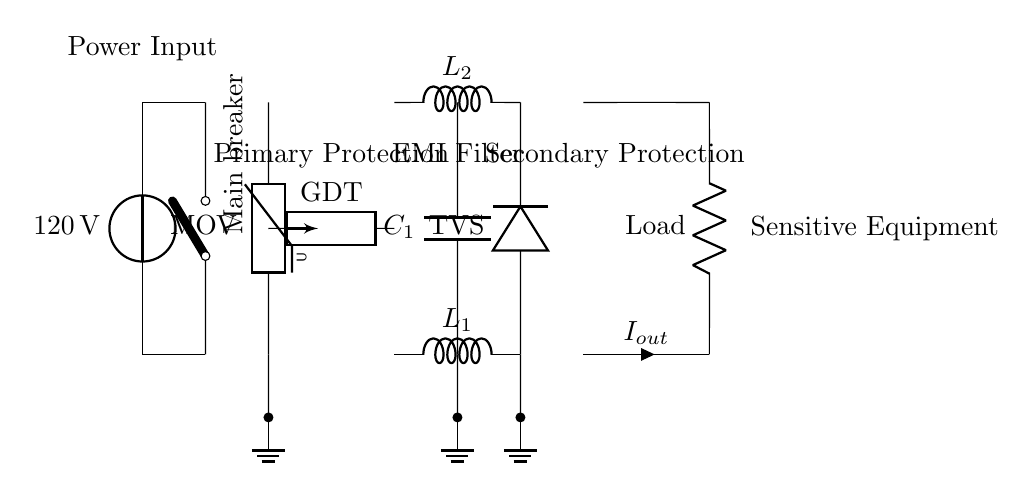What is the type of main power input? The main power input is provided by a voltage source labeled as 120 volts. This is indicated by the vsource symbol at the start of the circuit.
Answer: 120 volts What component provides primary surge protection? The primary surge protection is provided by a metal oxide varistor, as shown by the part labeled MOV in the diagram. This component is specifically designed to clamp voltage spikes.
Answer: MOV How many inductors are in the EMI filter section? The EMI filter section contains two inductors labeled L1 and L2, which are connected in parallel with a capacitor labeled C1. This configuration is common for filtering out electromagnetic interference.
Answer: 2 What type of device is used for secondary protection? The secondary protection is provided by a transient voltage suppressor, indicated by the label TVS next to the corresponding diode symbol. This device is used to protect sensitive equipment from voltage spikes.
Answer: TVS Where are the ground connections located? Ground connections are shown at three different points in the circuit, marked by ground symbols connected to the MOV, C1, and TVS. These connections help to safely redirect excess voltage to the ground.
Answer: Three points What is the expected output current labeled as? The expected output current is labeled as Iout in the circuit, indicating the current that flows to the sensitive equipment. This is shown as an arrow with the label next to it, guiding from the circuit output to the load.
Answer: Iout What is the load represented in this circuit? The load in this circuit is represented by a resistor labeled Load, which is the final component the current flows through before reaching the connected sensitive equipment.
Answer: Load 